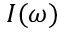<formula> <loc_0><loc_0><loc_500><loc_500>I ( \omega )</formula> 